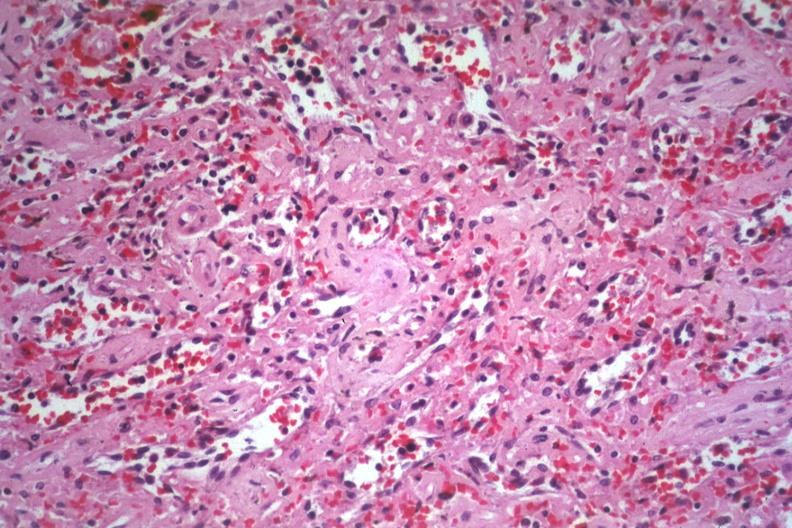what is present?
Answer the question using a single word or phrase. Spleen 